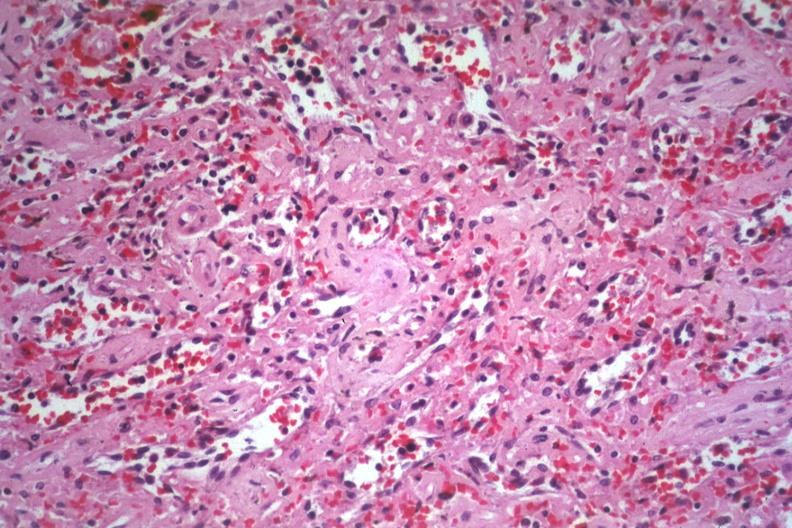what is present?
Answer the question using a single word or phrase. Spleen 